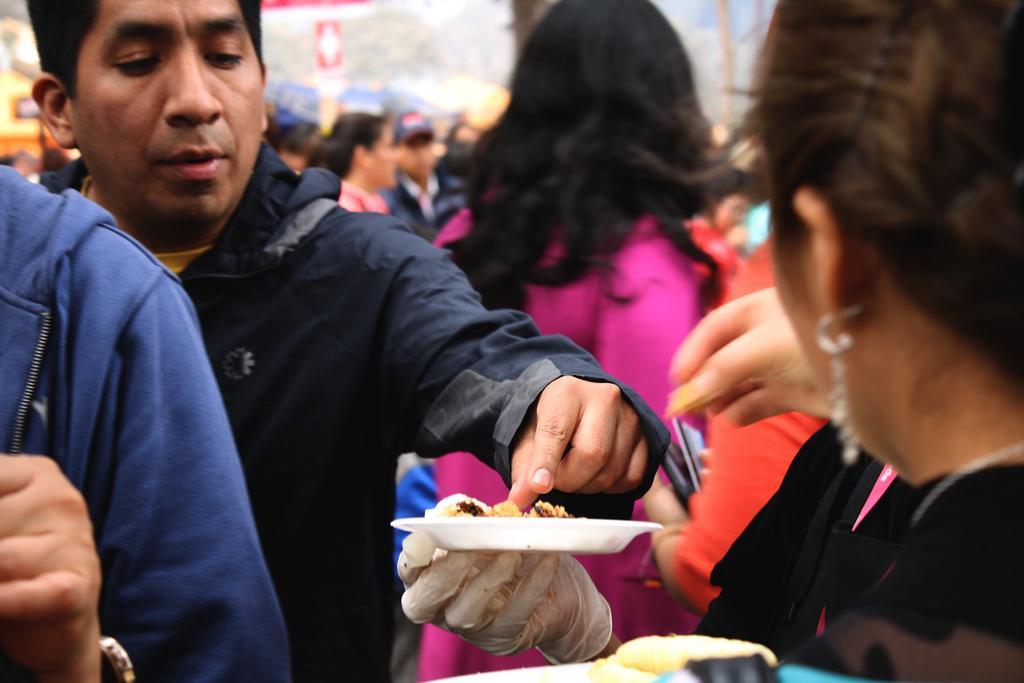In one or two sentences, can you explain what this image depicts? In this picture there are people and we can see plate with food hold with hand. In the background of the image it is blurry. 